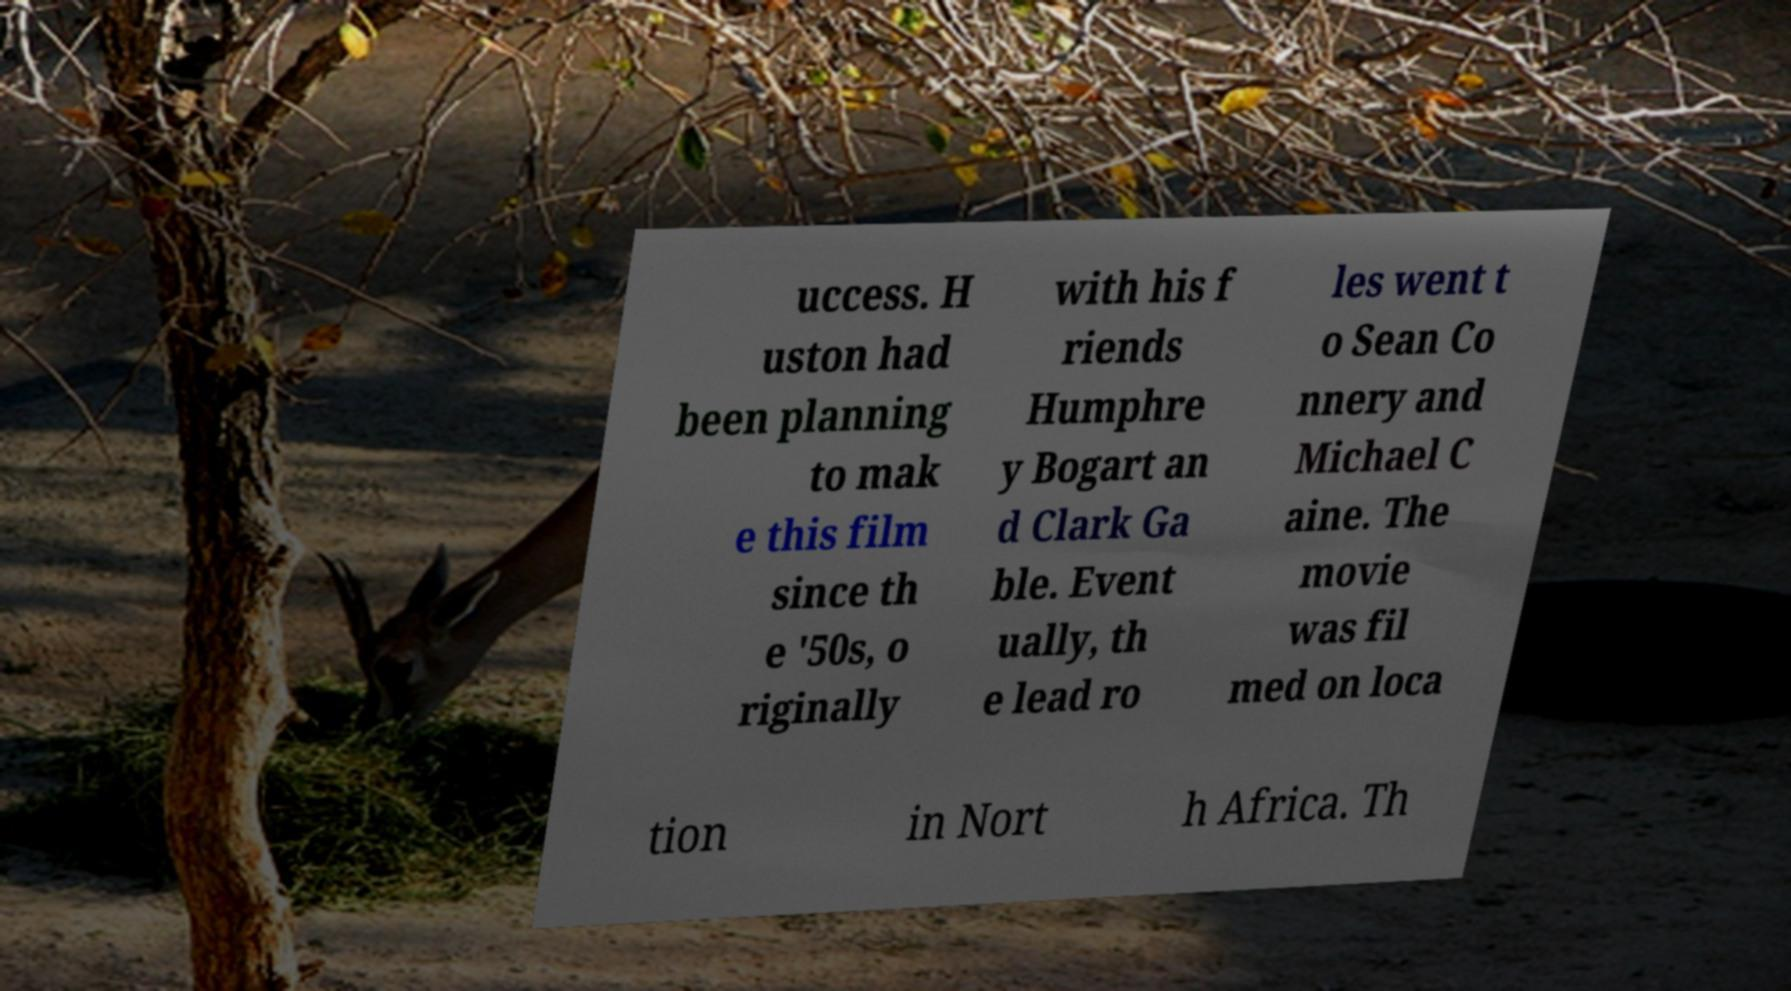There's text embedded in this image that I need extracted. Can you transcribe it verbatim? uccess. H uston had been planning to mak e this film since th e '50s, o riginally with his f riends Humphre y Bogart an d Clark Ga ble. Event ually, th e lead ro les went t o Sean Co nnery and Michael C aine. The movie was fil med on loca tion in Nort h Africa. Th 